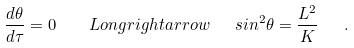Convert formula to latex. <formula><loc_0><loc_0><loc_500><loc_500>\frac { d \theta } { d \tau } = 0 \quad L o n g r i g h t a r r o w \ \ \ sin ^ { 2 } \theta = \frac { L ^ { 2 } } { K } \ \ \ .</formula> 